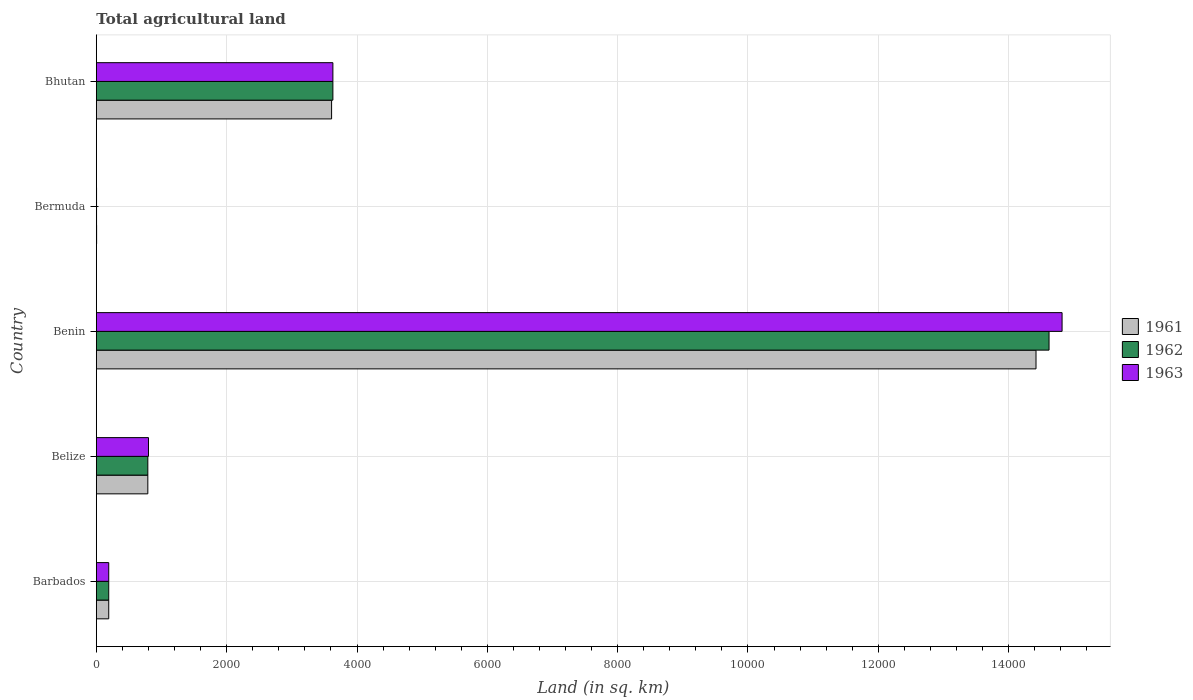How many different coloured bars are there?
Offer a terse response. 3. Are the number of bars per tick equal to the number of legend labels?
Ensure brevity in your answer.  Yes. Are the number of bars on each tick of the Y-axis equal?
Your answer should be compact. Yes. How many bars are there on the 5th tick from the top?
Your response must be concise. 3. How many bars are there on the 2nd tick from the bottom?
Your response must be concise. 3. What is the label of the 1st group of bars from the top?
Offer a terse response. Bhutan. In how many cases, is the number of bars for a given country not equal to the number of legend labels?
Give a very brief answer. 0. What is the total agricultural land in 1961 in Bhutan?
Give a very brief answer. 3610. Across all countries, what is the maximum total agricultural land in 1961?
Ensure brevity in your answer.  1.44e+04. Across all countries, what is the minimum total agricultural land in 1963?
Provide a short and direct response. 3. In which country was the total agricultural land in 1963 maximum?
Your answer should be compact. Benin. In which country was the total agricultural land in 1961 minimum?
Provide a succinct answer. Bermuda. What is the total total agricultural land in 1962 in the graph?
Offer a terse response. 1.92e+04. What is the difference between the total agricultural land in 1961 in Benin and that in Bermuda?
Make the answer very short. 1.44e+04. What is the difference between the total agricultural land in 1963 in Belize and the total agricultural land in 1962 in Bermuda?
Ensure brevity in your answer.  797. What is the average total agricultural land in 1962 per country?
Provide a succinct answer. 3846.6. What is the difference between the total agricultural land in 1961 and total agricultural land in 1962 in Benin?
Provide a succinct answer. -200. In how many countries, is the total agricultural land in 1961 greater than 13200 sq.km?
Provide a short and direct response. 1. What is the ratio of the total agricultural land in 1963 in Belize to that in Bhutan?
Offer a very short reply. 0.22. Is the total agricultural land in 1961 in Barbados less than that in Belize?
Your answer should be very brief. Yes. Is the difference between the total agricultural land in 1961 in Bermuda and Bhutan greater than the difference between the total agricultural land in 1962 in Bermuda and Bhutan?
Keep it short and to the point. Yes. What is the difference between the highest and the second highest total agricultural land in 1961?
Make the answer very short. 1.08e+04. What is the difference between the highest and the lowest total agricultural land in 1963?
Make the answer very short. 1.48e+04. In how many countries, is the total agricultural land in 1963 greater than the average total agricultural land in 1963 taken over all countries?
Make the answer very short. 1. Is the sum of the total agricultural land in 1962 in Belize and Benin greater than the maximum total agricultural land in 1961 across all countries?
Give a very brief answer. Yes. How many bars are there?
Offer a very short reply. 15. Are all the bars in the graph horizontal?
Offer a very short reply. Yes. How many countries are there in the graph?
Ensure brevity in your answer.  5. Does the graph contain any zero values?
Your response must be concise. No. Does the graph contain grids?
Your response must be concise. Yes. Where does the legend appear in the graph?
Provide a short and direct response. Center right. How many legend labels are there?
Your answer should be compact. 3. How are the legend labels stacked?
Provide a succinct answer. Vertical. What is the title of the graph?
Offer a very short reply. Total agricultural land. What is the label or title of the X-axis?
Make the answer very short. Land (in sq. km). What is the label or title of the Y-axis?
Keep it short and to the point. Country. What is the Land (in sq. km) in 1961 in Barbados?
Offer a very short reply. 190. What is the Land (in sq. km) in 1962 in Barbados?
Make the answer very short. 190. What is the Land (in sq. km) in 1963 in Barbados?
Keep it short and to the point. 190. What is the Land (in sq. km) of 1961 in Belize?
Provide a succinct answer. 790. What is the Land (in sq. km) in 1962 in Belize?
Keep it short and to the point. 790. What is the Land (in sq. km) of 1963 in Belize?
Provide a succinct answer. 800. What is the Land (in sq. km) in 1961 in Benin?
Your answer should be very brief. 1.44e+04. What is the Land (in sq. km) in 1962 in Benin?
Ensure brevity in your answer.  1.46e+04. What is the Land (in sq. km) of 1963 in Benin?
Your response must be concise. 1.48e+04. What is the Land (in sq. km) in 1962 in Bermuda?
Keep it short and to the point. 3. What is the Land (in sq. km) of 1963 in Bermuda?
Keep it short and to the point. 3. What is the Land (in sq. km) in 1961 in Bhutan?
Keep it short and to the point. 3610. What is the Land (in sq. km) of 1962 in Bhutan?
Give a very brief answer. 3630. What is the Land (in sq. km) of 1963 in Bhutan?
Your answer should be compact. 3630. Across all countries, what is the maximum Land (in sq. km) in 1961?
Keep it short and to the point. 1.44e+04. Across all countries, what is the maximum Land (in sq. km) of 1962?
Offer a very short reply. 1.46e+04. Across all countries, what is the maximum Land (in sq. km) in 1963?
Keep it short and to the point. 1.48e+04. What is the total Land (in sq. km) in 1961 in the graph?
Make the answer very short. 1.90e+04. What is the total Land (in sq. km) of 1962 in the graph?
Your answer should be very brief. 1.92e+04. What is the total Land (in sq. km) in 1963 in the graph?
Provide a short and direct response. 1.94e+04. What is the difference between the Land (in sq. km) in 1961 in Barbados and that in Belize?
Make the answer very short. -600. What is the difference between the Land (in sq. km) of 1962 in Barbados and that in Belize?
Give a very brief answer. -600. What is the difference between the Land (in sq. km) in 1963 in Barbados and that in Belize?
Your answer should be compact. -610. What is the difference between the Land (in sq. km) in 1961 in Barbados and that in Benin?
Make the answer very short. -1.42e+04. What is the difference between the Land (in sq. km) in 1962 in Barbados and that in Benin?
Your response must be concise. -1.44e+04. What is the difference between the Land (in sq. km) of 1963 in Barbados and that in Benin?
Offer a terse response. -1.46e+04. What is the difference between the Land (in sq. km) of 1961 in Barbados and that in Bermuda?
Keep it short and to the point. 186. What is the difference between the Land (in sq. km) of 1962 in Barbados and that in Bermuda?
Give a very brief answer. 187. What is the difference between the Land (in sq. km) in 1963 in Barbados and that in Bermuda?
Keep it short and to the point. 187. What is the difference between the Land (in sq. km) in 1961 in Barbados and that in Bhutan?
Your answer should be compact. -3420. What is the difference between the Land (in sq. km) in 1962 in Barbados and that in Bhutan?
Provide a short and direct response. -3440. What is the difference between the Land (in sq. km) in 1963 in Barbados and that in Bhutan?
Make the answer very short. -3440. What is the difference between the Land (in sq. km) of 1961 in Belize and that in Benin?
Offer a terse response. -1.36e+04. What is the difference between the Land (in sq. km) of 1962 in Belize and that in Benin?
Your answer should be very brief. -1.38e+04. What is the difference between the Land (in sq. km) in 1963 in Belize and that in Benin?
Offer a terse response. -1.40e+04. What is the difference between the Land (in sq. km) of 1961 in Belize and that in Bermuda?
Ensure brevity in your answer.  786. What is the difference between the Land (in sq. km) in 1962 in Belize and that in Bermuda?
Your response must be concise. 787. What is the difference between the Land (in sq. km) in 1963 in Belize and that in Bermuda?
Offer a terse response. 797. What is the difference between the Land (in sq. km) of 1961 in Belize and that in Bhutan?
Provide a succinct answer. -2820. What is the difference between the Land (in sq. km) in 1962 in Belize and that in Bhutan?
Your answer should be very brief. -2840. What is the difference between the Land (in sq. km) of 1963 in Belize and that in Bhutan?
Give a very brief answer. -2830. What is the difference between the Land (in sq. km) in 1961 in Benin and that in Bermuda?
Ensure brevity in your answer.  1.44e+04. What is the difference between the Land (in sq. km) in 1962 in Benin and that in Bermuda?
Your response must be concise. 1.46e+04. What is the difference between the Land (in sq. km) of 1963 in Benin and that in Bermuda?
Offer a very short reply. 1.48e+04. What is the difference between the Land (in sq. km) of 1961 in Benin and that in Bhutan?
Make the answer very short. 1.08e+04. What is the difference between the Land (in sq. km) of 1962 in Benin and that in Bhutan?
Keep it short and to the point. 1.10e+04. What is the difference between the Land (in sq. km) of 1963 in Benin and that in Bhutan?
Provide a short and direct response. 1.12e+04. What is the difference between the Land (in sq. km) in 1961 in Bermuda and that in Bhutan?
Your response must be concise. -3606. What is the difference between the Land (in sq. km) of 1962 in Bermuda and that in Bhutan?
Ensure brevity in your answer.  -3627. What is the difference between the Land (in sq. km) of 1963 in Bermuda and that in Bhutan?
Keep it short and to the point. -3627. What is the difference between the Land (in sq. km) of 1961 in Barbados and the Land (in sq. km) of 1962 in Belize?
Your answer should be very brief. -600. What is the difference between the Land (in sq. km) in 1961 in Barbados and the Land (in sq. km) in 1963 in Belize?
Your answer should be very brief. -610. What is the difference between the Land (in sq. km) in 1962 in Barbados and the Land (in sq. km) in 1963 in Belize?
Provide a succinct answer. -610. What is the difference between the Land (in sq. km) in 1961 in Barbados and the Land (in sq. km) in 1962 in Benin?
Your response must be concise. -1.44e+04. What is the difference between the Land (in sq. km) in 1961 in Barbados and the Land (in sq. km) in 1963 in Benin?
Provide a succinct answer. -1.46e+04. What is the difference between the Land (in sq. km) of 1962 in Barbados and the Land (in sq. km) of 1963 in Benin?
Your answer should be very brief. -1.46e+04. What is the difference between the Land (in sq. km) in 1961 in Barbados and the Land (in sq. km) in 1962 in Bermuda?
Keep it short and to the point. 187. What is the difference between the Land (in sq. km) of 1961 in Barbados and the Land (in sq. km) of 1963 in Bermuda?
Keep it short and to the point. 187. What is the difference between the Land (in sq. km) in 1962 in Barbados and the Land (in sq. km) in 1963 in Bermuda?
Make the answer very short. 187. What is the difference between the Land (in sq. km) of 1961 in Barbados and the Land (in sq. km) of 1962 in Bhutan?
Ensure brevity in your answer.  -3440. What is the difference between the Land (in sq. km) in 1961 in Barbados and the Land (in sq. km) in 1963 in Bhutan?
Your answer should be very brief. -3440. What is the difference between the Land (in sq. km) of 1962 in Barbados and the Land (in sq. km) of 1963 in Bhutan?
Provide a succinct answer. -3440. What is the difference between the Land (in sq. km) of 1961 in Belize and the Land (in sq. km) of 1962 in Benin?
Offer a very short reply. -1.38e+04. What is the difference between the Land (in sq. km) in 1961 in Belize and the Land (in sq. km) in 1963 in Benin?
Ensure brevity in your answer.  -1.40e+04. What is the difference between the Land (in sq. km) of 1962 in Belize and the Land (in sq. km) of 1963 in Benin?
Keep it short and to the point. -1.40e+04. What is the difference between the Land (in sq. km) in 1961 in Belize and the Land (in sq. km) in 1962 in Bermuda?
Keep it short and to the point. 787. What is the difference between the Land (in sq. km) in 1961 in Belize and the Land (in sq. km) in 1963 in Bermuda?
Provide a short and direct response. 787. What is the difference between the Land (in sq. km) in 1962 in Belize and the Land (in sq. km) in 1963 in Bermuda?
Provide a succinct answer. 787. What is the difference between the Land (in sq. km) in 1961 in Belize and the Land (in sq. km) in 1962 in Bhutan?
Offer a very short reply. -2840. What is the difference between the Land (in sq. km) of 1961 in Belize and the Land (in sq. km) of 1963 in Bhutan?
Offer a terse response. -2840. What is the difference between the Land (in sq. km) in 1962 in Belize and the Land (in sq. km) in 1963 in Bhutan?
Provide a short and direct response. -2840. What is the difference between the Land (in sq. km) of 1961 in Benin and the Land (in sq. km) of 1962 in Bermuda?
Make the answer very short. 1.44e+04. What is the difference between the Land (in sq. km) in 1961 in Benin and the Land (in sq. km) in 1963 in Bermuda?
Your response must be concise. 1.44e+04. What is the difference between the Land (in sq. km) of 1962 in Benin and the Land (in sq. km) of 1963 in Bermuda?
Your response must be concise. 1.46e+04. What is the difference between the Land (in sq. km) of 1961 in Benin and the Land (in sq. km) of 1962 in Bhutan?
Give a very brief answer. 1.08e+04. What is the difference between the Land (in sq. km) in 1961 in Benin and the Land (in sq. km) in 1963 in Bhutan?
Your answer should be compact. 1.08e+04. What is the difference between the Land (in sq. km) of 1962 in Benin and the Land (in sq. km) of 1963 in Bhutan?
Provide a short and direct response. 1.10e+04. What is the difference between the Land (in sq. km) of 1961 in Bermuda and the Land (in sq. km) of 1962 in Bhutan?
Ensure brevity in your answer.  -3626. What is the difference between the Land (in sq. km) in 1961 in Bermuda and the Land (in sq. km) in 1963 in Bhutan?
Your answer should be compact. -3626. What is the difference between the Land (in sq. km) of 1962 in Bermuda and the Land (in sq. km) of 1963 in Bhutan?
Make the answer very short. -3627. What is the average Land (in sq. km) of 1961 per country?
Give a very brief answer. 3802.8. What is the average Land (in sq. km) of 1962 per country?
Provide a short and direct response. 3846.6. What is the average Land (in sq. km) in 1963 per country?
Provide a succinct answer. 3888.6. What is the difference between the Land (in sq. km) of 1961 and Land (in sq. km) of 1963 in Barbados?
Provide a short and direct response. 0. What is the difference between the Land (in sq. km) in 1961 and Land (in sq. km) in 1962 in Belize?
Your response must be concise. 0. What is the difference between the Land (in sq. km) of 1961 and Land (in sq. km) of 1963 in Belize?
Offer a terse response. -10. What is the difference between the Land (in sq. km) in 1961 and Land (in sq. km) in 1962 in Benin?
Offer a very short reply. -200. What is the difference between the Land (in sq. km) in 1961 and Land (in sq. km) in 1963 in Benin?
Provide a short and direct response. -400. What is the difference between the Land (in sq. km) in 1962 and Land (in sq. km) in 1963 in Benin?
Offer a terse response. -200. What is the difference between the Land (in sq. km) in 1961 and Land (in sq. km) in 1963 in Bermuda?
Make the answer very short. 1. What is the ratio of the Land (in sq. km) of 1961 in Barbados to that in Belize?
Your answer should be very brief. 0.24. What is the ratio of the Land (in sq. km) of 1962 in Barbados to that in Belize?
Offer a terse response. 0.24. What is the ratio of the Land (in sq. km) in 1963 in Barbados to that in Belize?
Offer a very short reply. 0.24. What is the ratio of the Land (in sq. km) in 1961 in Barbados to that in Benin?
Provide a short and direct response. 0.01. What is the ratio of the Land (in sq. km) of 1962 in Barbados to that in Benin?
Provide a short and direct response. 0.01. What is the ratio of the Land (in sq. km) of 1963 in Barbados to that in Benin?
Provide a short and direct response. 0.01. What is the ratio of the Land (in sq. km) in 1961 in Barbados to that in Bermuda?
Keep it short and to the point. 47.5. What is the ratio of the Land (in sq. km) of 1962 in Barbados to that in Bermuda?
Keep it short and to the point. 63.33. What is the ratio of the Land (in sq. km) in 1963 in Barbados to that in Bermuda?
Give a very brief answer. 63.33. What is the ratio of the Land (in sq. km) in 1961 in Barbados to that in Bhutan?
Offer a terse response. 0.05. What is the ratio of the Land (in sq. km) of 1962 in Barbados to that in Bhutan?
Provide a short and direct response. 0.05. What is the ratio of the Land (in sq. km) in 1963 in Barbados to that in Bhutan?
Ensure brevity in your answer.  0.05. What is the ratio of the Land (in sq. km) in 1961 in Belize to that in Benin?
Your response must be concise. 0.05. What is the ratio of the Land (in sq. km) in 1962 in Belize to that in Benin?
Your answer should be very brief. 0.05. What is the ratio of the Land (in sq. km) in 1963 in Belize to that in Benin?
Your response must be concise. 0.05. What is the ratio of the Land (in sq. km) of 1961 in Belize to that in Bermuda?
Make the answer very short. 197.5. What is the ratio of the Land (in sq. km) in 1962 in Belize to that in Bermuda?
Provide a succinct answer. 263.33. What is the ratio of the Land (in sq. km) in 1963 in Belize to that in Bermuda?
Your answer should be very brief. 266.67. What is the ratio of the Land (in sq. km) in 1961 in Belize to that in Bhutan?
Make the answer very short. 0.22. What is the ratio of the Land (in sq. km) of 1962 in Belize to that in Bhutan?
Make the answer very short. 0.22. What is the ratio of the Land (in sq. km) of 1963 in Belize to that in Bhutan?
Ensure brevity in your answer.  0.22. What is the ratio of the Land (in sq. km) in 1961 in Benin to that in Bermuda?
Offer a very short reply. 3605. What is the ratio of the Land (in sq. km) in 1962 in Benin to that in Bermuda?
Keep it short and to the point. 4873.33. What is the ratio of the Land (in sq. km) in 1963 in Benin to that in Bermuda?
Your answer should be very brief. 4940. What is the ratio of the Land (in sq. km) of 1961 in Benin to that in Bhutan?
Provide a short and direct response. 3.99. What is the ratio of the Land (in sq. km) in 1962 in Benin to that in Bhutan?
Provide a short and direct response. 4.03. What is the ratio of the Land (in sq. km) in 1963 in Benin to that in Bhutan?
Your response must be concise. 4.08. What is the ratio of the Land (in sq. km) of 1961 in Bermuda to that in Bhutan?
Keep it short and to the point. 0. What is the ratio of the Land (in sq. km) in 1962 in Bermuda to that in Bhutan?
Provide a succinct answer. 0. What is the ratio of the Land (in sq. km) of 1963 in Bermuda to that in Bhutan?
Keep it short and to the point. 0. What is the difference between the highest and the second highest Land (in sq. km) in 1961?
Offer a very short reply. 1.08e+04. What is the difference between the highest and the second highest Land (in sq. km) of 1962?
Ensure brevity in your answer.  1.10e+04. What is the difference between the highest and the second highest Land (in sq. km) in 1963?
Your answer should be compact. 1.12e+04. What is the difference between the highest and the lowest Land (in sq. km) in 1961?
Your response must be concise. 1.44e+04. What is the difference between the highest and the lowest Land (in sq. km) of 1962?
Offer a terse response. 1.46e+04. What is the difference between the highest and the lowest Land (in sq. km) of 1963?
Offer a terse response. 1.48e+04. 